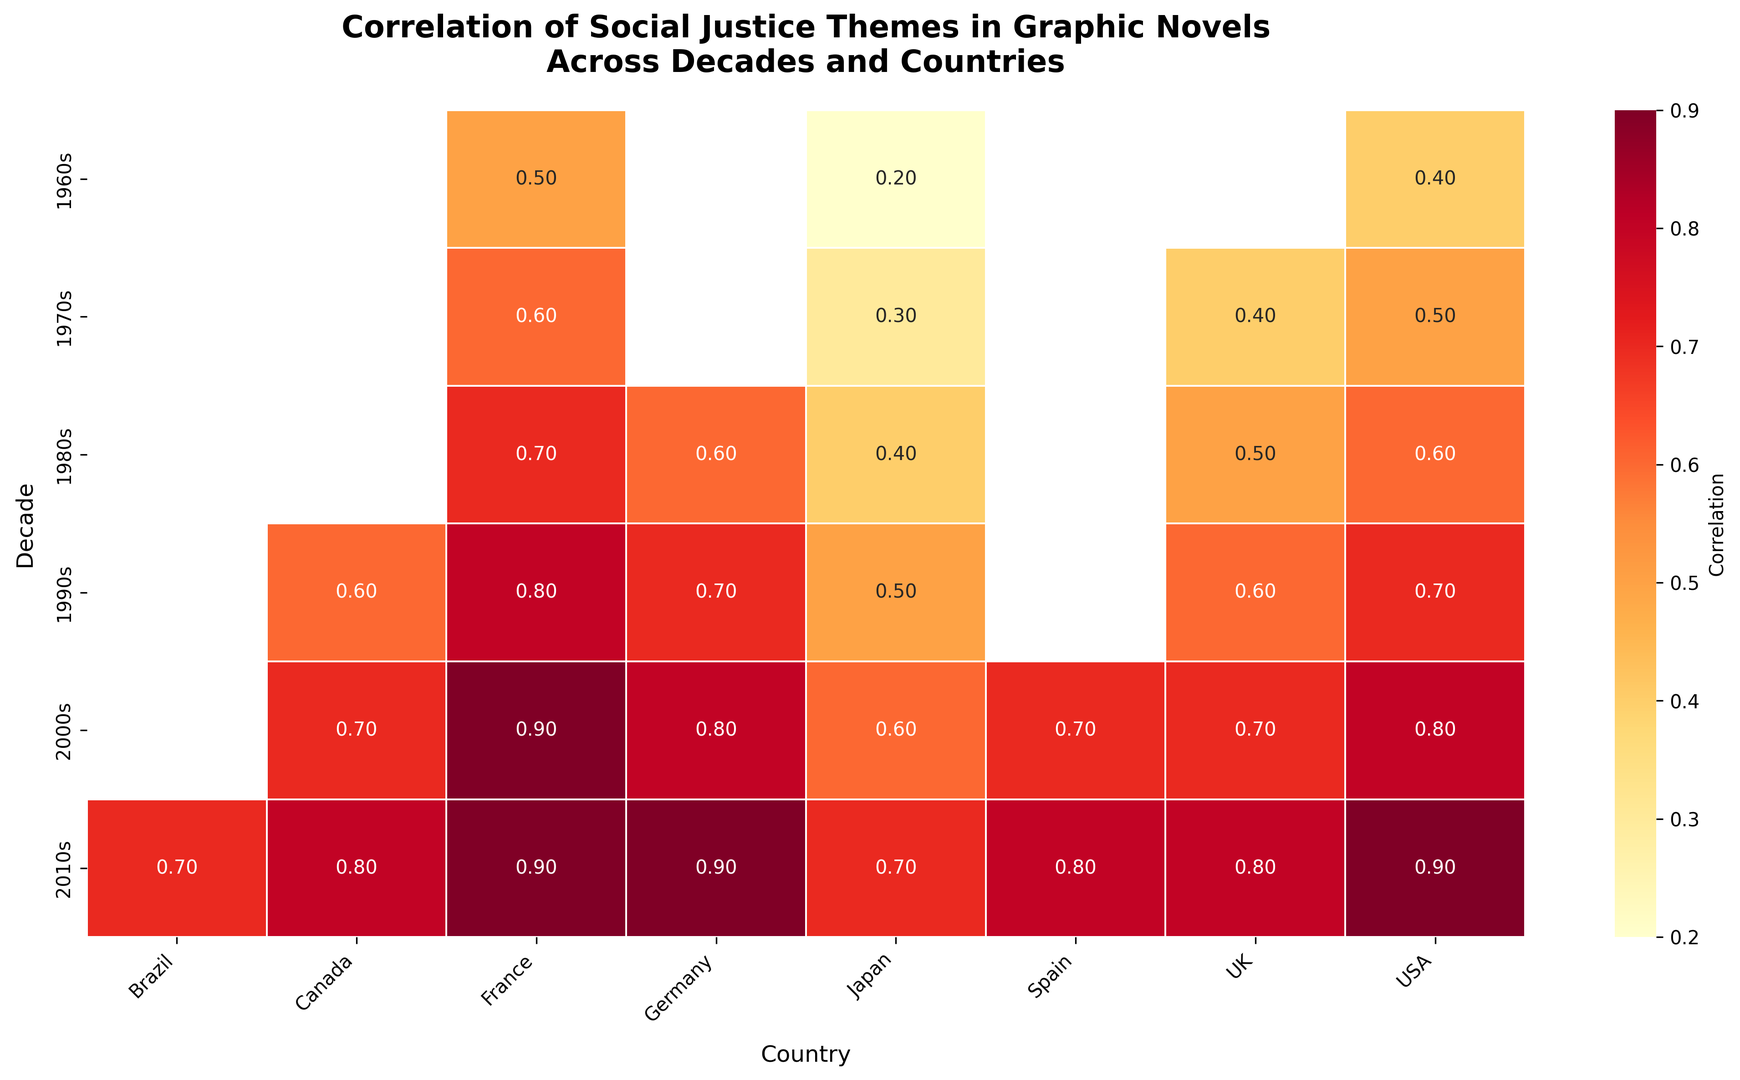What is the highest correlation value for social justice themes in graphic novels for the 2000s? Look for the decade '2000s' on the y-axis. Then, identify the highest value among the countries listed in the '2000s' row. The highest value is 0.9 for France.
Answer: 0.9 Which country shows a consistent increase in correlation values for social justice themes in graphic novels from the 1960s to the 2010s? Check the heatmap for consistent increases in the values across all represented decades for each country. Japan shows a consistent increase from 0.2 in the 1960s to 0.7 in the 2010s.
Answer: Japan In which decade does the USA have the highest correlation value for social justice themes? Locate the row for the USA in each decade and compare the values across them. The highest value for the USA is in the 2010s.
Answer: 2010s Which country exhibits the least increase in correlation values for social justice themes between the 1960s and the 2010s? Find the difference in values for each country between the 1960s and the 2010s. The least increase is for Japan, from 0.2 to 0.7 (0.5 increase).
Answer: Japan What is the average correlation value for social justice themes in graphic novels in the 1980s across all countries? Add all the values for the social justice themes in the 1980s and divide by the number of countries represented in that decade. (0.6 + 0.4 + 0.7 + 0.5 + 0.6)/5 = 2.8/5 = 0.56
Answer: 0.56 Compare the correlation values for social justice themes between Germany and Canada in the 2000s. Which country has a higher correlation and by how much? Identify the values for Germany and Canada in the 2000s. Germany has a value of 0.8 and Canada has 0.7. The difference is 0.1, with Germany having a higher correlation.
Answer: Germany, by 0.1 Which country showed a significant jump in correlation values from the 1990s to the 2000s? Compare the two decades' values for each country. The largest jump is observed for France, from 0.8 to 0.9.
Answer: France How does the correlation value for social justice themes in graphic novels in the UK compare between the 1970s and the 2010s? Locate the UK values in the 1970s and 2010s. The values are 0.4 in the 1970s and 0.8 in the 2010s. The value has increased by 0.4.
Answer: 0.4 increase 